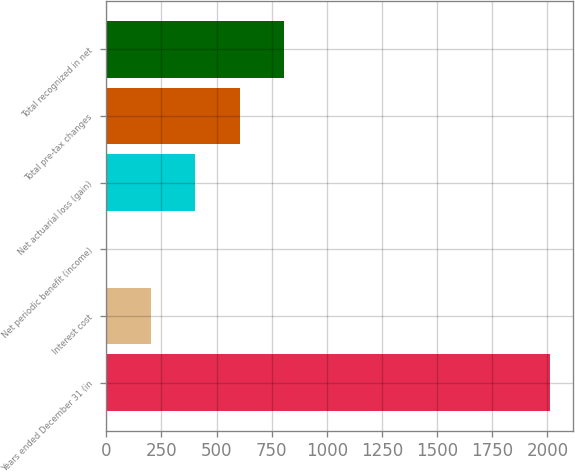Convert chart. <chart><loc_0><loc_0><loc_500><loc_500><bar_chart><fcel>Years ended December 31 (in<fcel>Interest cost<fcel>Net periodic benefit (income)<fcel>Net actuarial loss (gain)<fcel>Total pre-tax changes<fcel>Total recognized in net<nl><fcel>2013<fcel>203.37<fcel>2.3<fcel>404.44<fcel>605.51<fcel>806.58<nl></chart> 